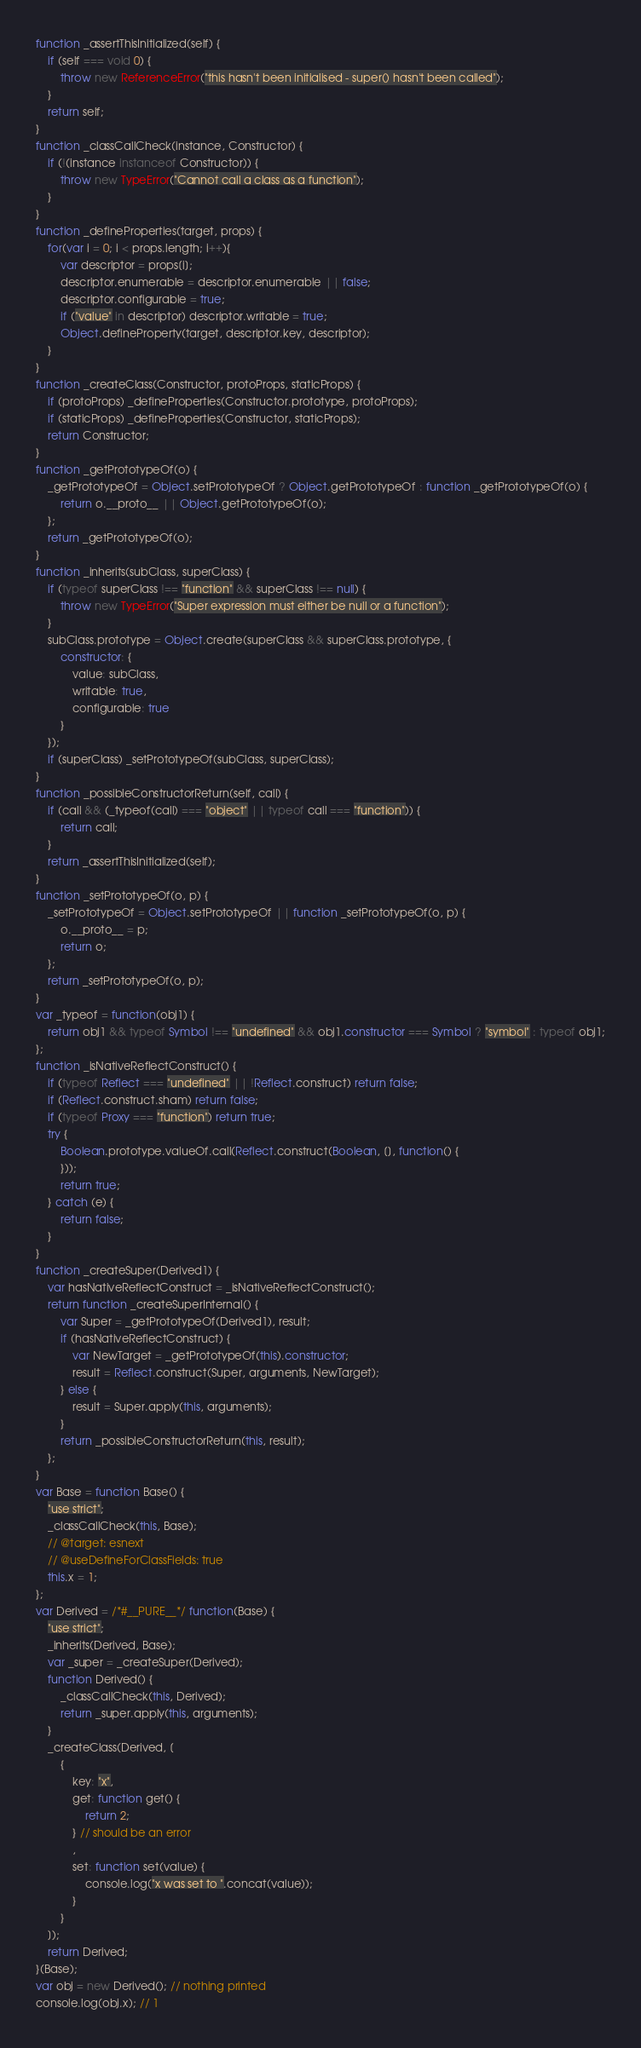<code> <loc_0><loc_0><loc_500><loc_500><_JavaScript_>function _assertThisInitialized(self) {
    if (self === void 0) {
        throw new ReferenceError("this hasn't been initialised - super() hasn't been called");
    }
    return self;
}
function _classCallCheck(instance, Constructor) {
    if (!(instance instanceof Constructor)) {
        throw new TypeError("Cannot call a class as a function");
    }
}
function _defineProperties(target, props) {
    for(var i = 0; i < props.length; i++){
        var descriptor = props[i];
        descriptor.enumerable = descriptor.enumerable || false;
        descriptor.configurable = true;
        if ("value" in descriptor) descriptor.writable = true;
        Object.defineProperty(target, descriptor.key, descriptor);
    }
}
function _createClass(Constructor, protoProps, staticProps) {
    if (protoProps) _defineProperties(Constructor.prototype, protoProps);
    if (staticProps) _defineProperties(Constructor, staticProps);
    return Constructor;
}
function _getPrototypeOf(o) {
    _getPrototypeOf = Object.setPrototypeOf ? Object.getPrototypeOf : function _getPrototypeOf(o) {
        return o.__proto__ || Object.getPrototypeOf(o);
    };
    return _getPrototypeOf(o);
}
function _inherits(subClass, superClass) {
    if (typeof superClass !== "function" && superClass !== null) {
        throw new TypeError("Super expression must either be null or a function");
    }
    subClass.prototype = Object.create(superClass && superClass.prototype, {
        constructor: {
            value: subClass,
            writable: true,
            configurable: true
        }
    });
    if (superClass) _setPrototypeOf(subClass, superClass);
}
function _possibleConstructorReturn(self, call) {
    if (call && (_typeof(call) === "object" || typeof call === "function")) {
        return call;
    }
    return _assertThisInitialized(self);
}
function _setPrototypeOf(o, p) {
    _setPrototypeOf = Object.setPrototypeOf || function _setPrototypeOf(o, p) {
        o.__proto__ = p;
        return o;
    };
    return _setPrototypeOf(o, p);
}
var _typeof = function(obj1) {
    return obj1 && typeof Symbol !== "undefined" && obj1.constructor === Symbol ? "symbol" : typeof obj1;
};
function _isNativeReflectConstruct() {
    if (typeof Reflect === "undefined" || !Reflect.construct) return false;
    if (Reflect.construct.sham) return false;
    if (typeof Proxy === "function") return true;
    try {
        Boolean.prototype.valueOf.call(Reflect.construct(Boolean, [], function() {
        }));
        return true;
    } catch (e) {
        return false;
    }
}
function _createSuper(Derived1) {
    var hasNativeReflectConstruct = _isNativeReflectConstruct();
    return function _createSuperInternal() {
        var Super = _getPrototypeOf(Derived1), result;
        if (hasNativeReflectConstruct) {
            var NewTarget = _getPrototypeOf(this).constructor;
            result = Reflect.construct(Super, arguments, NewTarget);
        } else {
            result = Super.apply(this, arguments);
        }
        return _possibleConstructorReturn(this, result);
    };
}
var Base = function Base() {
    "use strict";
    _classCallCheck(this, Base);
    // @target: esnext
    // @useDefineForClassFields: true
    this.x = 1;
};
var Derived = /*#__PURE__*/ function(Base) {
    "use strict";
    _inherits(Derived, Base);
    var _super = _createSuper(Derived);
    function Derived() {
        _classCallCheck(this, Derived);
        return _super.apply(this, arguments);
    }
    _createClass(Derived, [
        {
            key: "x",
            get: function get() {
                return 2;
            } // should be an error
            ,
            set: function set(value) {
                console.log("x was set to ".concat(value));
            }
        }
    ]);
    return Derived;
}(Base);
var obj = new Derived(); // nothing printed
console.log(obj.x); // 1
</code> 